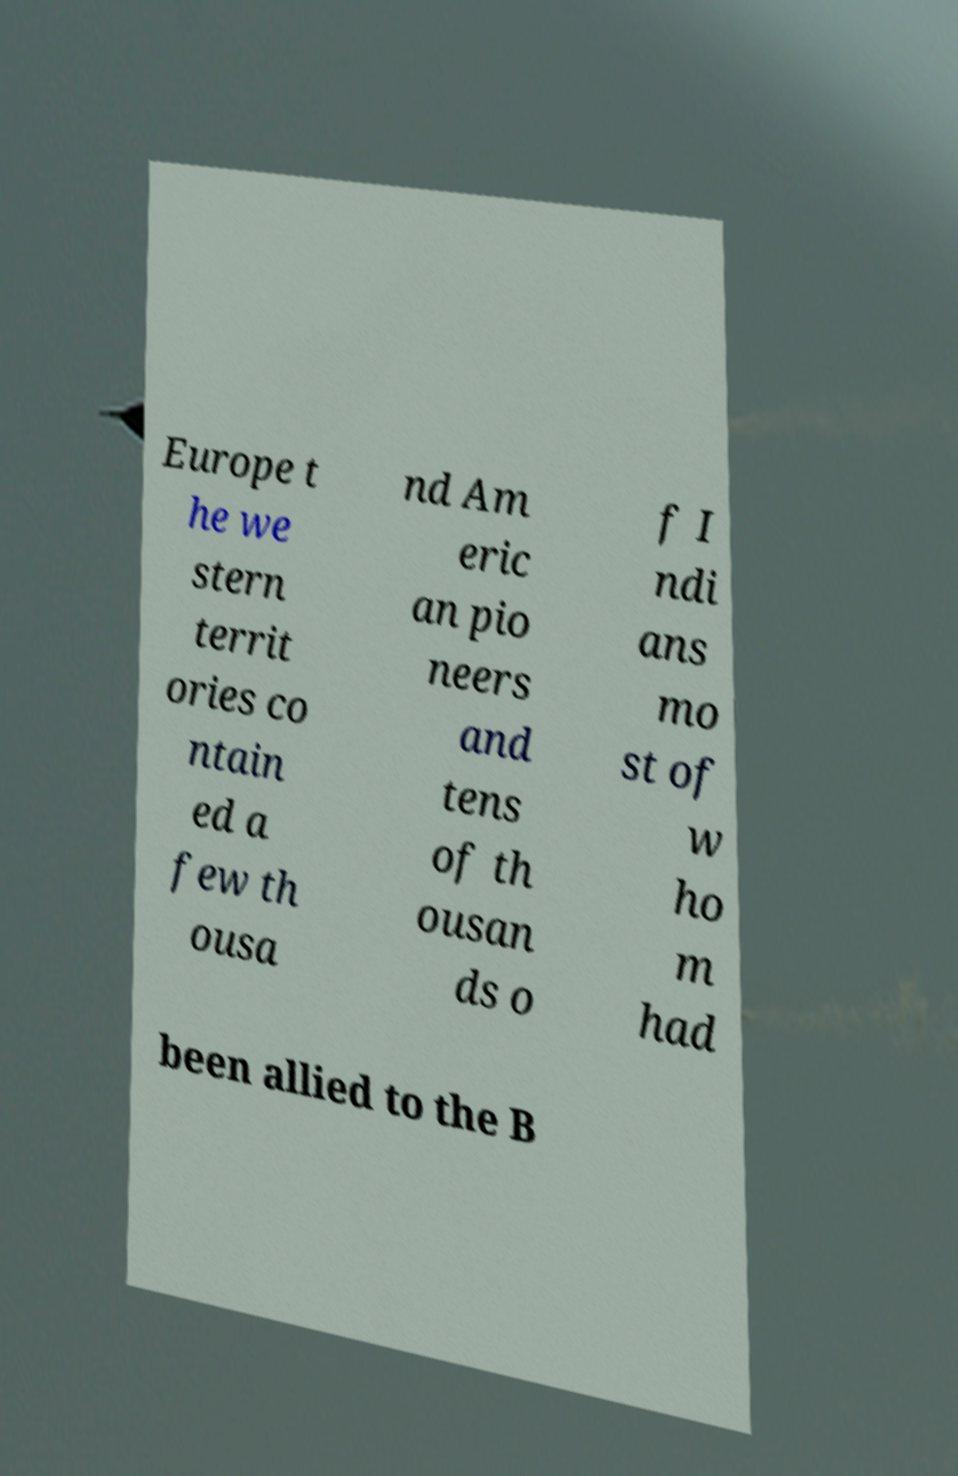What messages or text are displayed in this image? I need them in a readable, typed format. Europe t he we stern territ ories co ntain ed a few th ousa nd Am eric an pio neers and tens of th ousan ds o f I ndi ans mo st of w ho m had been allied to the B 